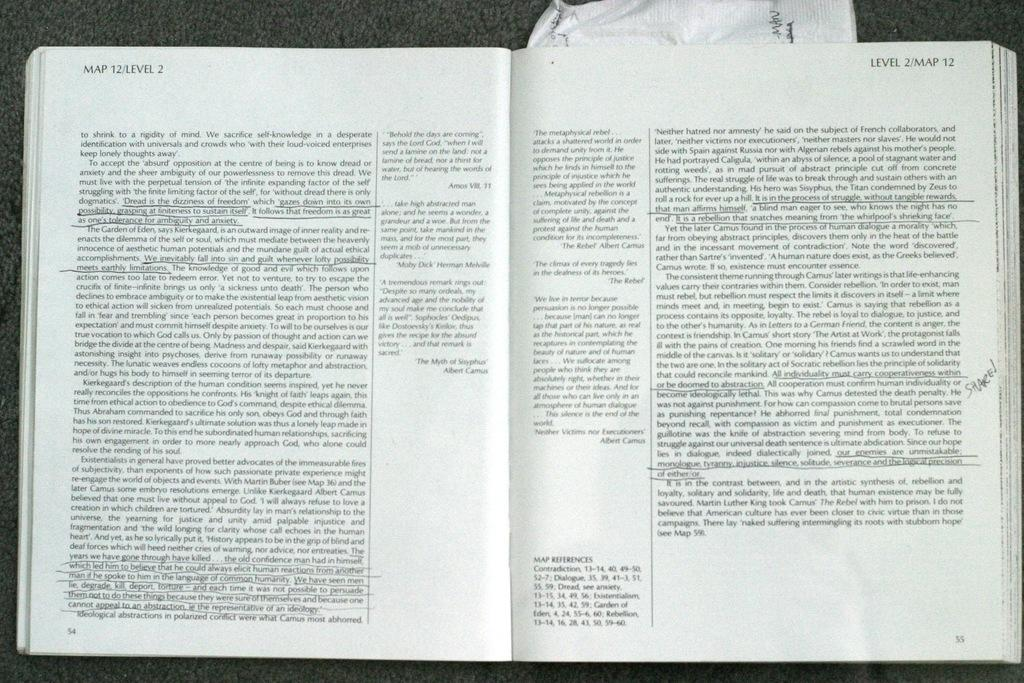<image>
Summarize the visual content of the image. two pages of an open book, the words 'Map 12/Level 2' written on the top left 